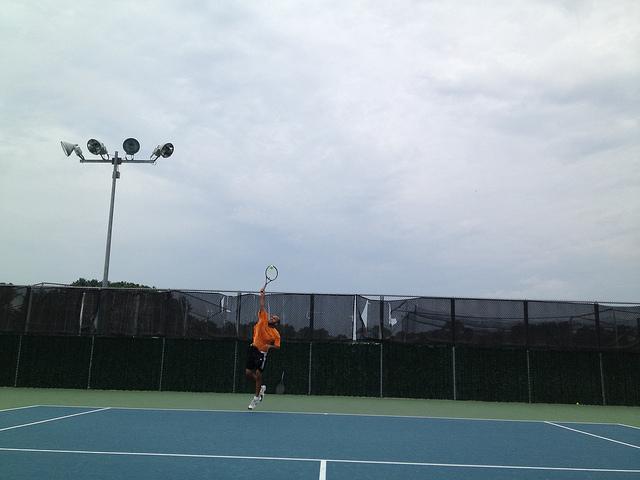Is it storming?
Keep it brief. No. How many lights are there?
Write a very short answer. 4. What color is the player's shirt?
Keep it brief. Orange. 